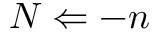<formula> <loc_0><loc_0><loc_500><loc_500>N \Leftarrow - n</formula> 